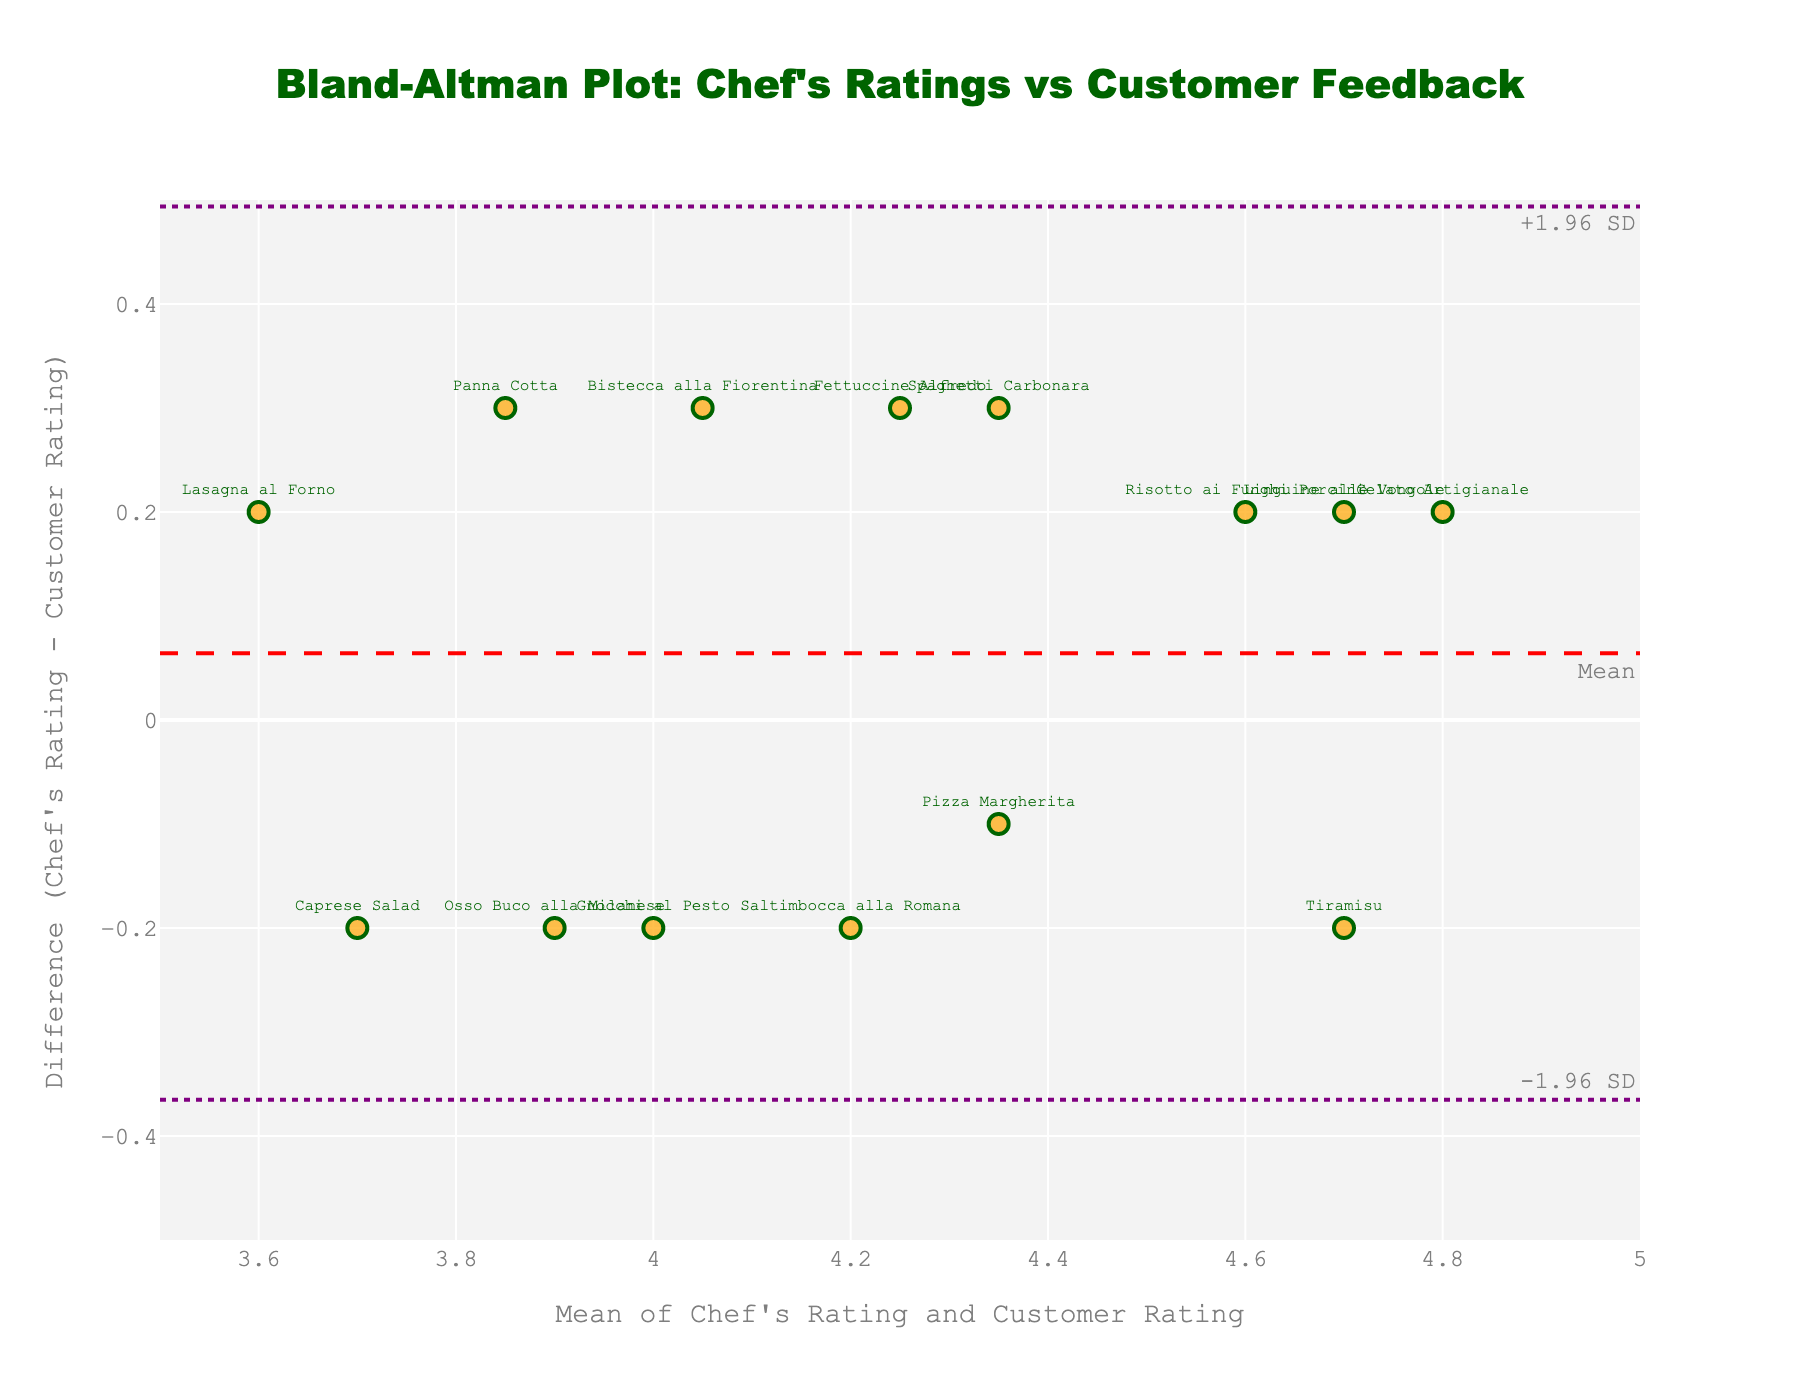What is the title of the plot? The title is typically located at the top of the figure. In this case, it is clearly specified at the top.
Answer: Bland-Altman Plot: Chef's Ratings vs Customer Feedback What do the x-axis and y-axis represent? The x-axis title reads "Mean of Chef's Rating and Customer Rating," and the y-axis title reads "Difference (Chef's Rating - Customer Rating)." These titles directly describe what each axis represents.
Answer: The x-axis represents the mean of Chef's Rating and Customer Rating, while the y-axis represents the difference between Chef's Rating and Customer Rating How many dishes were compared in this analysis? Each marker on the plot represents a dish. By counting the number of markers, we can determine the number of dishes.
Answer: 14 Which dish has the smallest difference between the Chef's Rating and the Customer Rating? To identify the dish with the smallest difference, look for the marker closest to the y-axis zero line. The text label near this marker indicates the dish's name.
Answer: Gnocchi al Pesto What are the upper and lower limits of agreement in this plot? The upper and lower limits of agreement are the dashed dotted lines annotated as "+1.96 SD" and "-1.96 SD," respectively. They are indicated by horizontal dashed dotted lines on the plot.
Answer: +0.3889 and -0.3889 What is the mean difference between the Chef's Rating and Customer Rating? The mean difference is represented by a red dashed horizontal line. It's labeled "Mean" on the plot.
Answer: 0.0428 Which dishes have a Chef's Rating higher than the Customer Rating? A Chef's Rating higher than a Customer Rating is indicated by a positive difference, points above the y=0 line. The labels near these points will give the dish names.
Answer: Spaghetti Carbonara, Risotto ai Funghi Porcini, Bistecca alla Fiorentina, Tiramisu, Pizza Margherita, Linguine alle Vongole, Saltimbocca alla Romana, Fettuccine Alfredo, Gelato Artigianale Which dishes have a Chef's Rating lower than the Customer Rating? A Chef's Rating lower than a Customer Rating is indicated by a negative difference, points below the zero line. The labels near these points will give the dish names.
Answer: Osso Buco alla Milanese, Gnocchi al Pesto, Panna Cotta, Lasagna al Forno, Caprese Salad How do the range of the x-axis and the y-axis compare? The x-axis ranges from 3.5 to 5 while the y-axis ranges from -0.5 to +0.5.
Answer: The x-axis range is larger (1.5) compared to the y-axis range (1) What is the most highly rated dish overall? The most highly rated dish would likely have the highest point on the x-axis, as it indicates the combined high mean rating between chef and customer. The label near this point identifies the dish.
Answer: Gelato Artigianale 